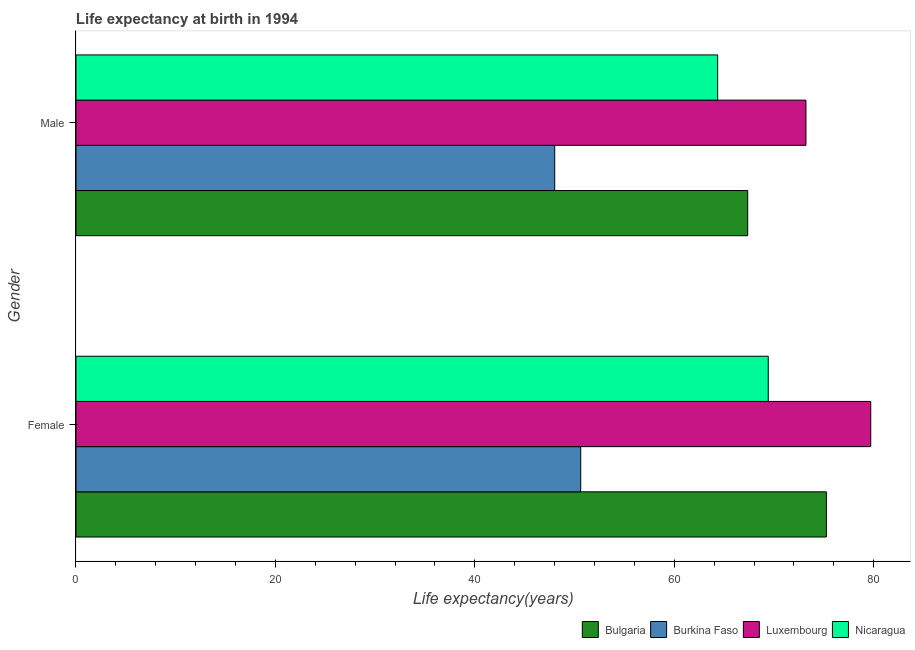Are the number of bars on each tick of the Y-axis equal?
Keep it short and to the point. Yes. How many bars are there on the 2nd tick from the top?
Your response must be concise. 4. What is the life expectancy(female) in Luxembourg?
Provide a short and direct response. 79.7. Across all countries, what is the maximum life expectancy(male)?
Offer a terse response. 73.2. Across all countries, what is the minimum life expectancy(male)?
Give a very brief answer. 48.01. In which country was the life expectancy(female) maximum?
Provide a succinct answer. Luxembourg. In which country was the life expectancy(male) minimum?
Your response must be concise. Burkina Faso. What is the total life expectancy(male) in the graph?
Give a very brief answer. 252.91. What is the difference between the life expectancy(male) in Nicaragua and that in Burkina Faso?
Ensure brevity in your answer.  16.34. What is the difference between the life expectancy(female) in Bulgaria and the life expectancy(male) in Nicaragua?
Give a very brief answer. 10.9. What is the average life expectancy(male) per country?
Give a very brief answer. 63.23. What is the difference between the life expectancy(male) and life expectancy(female) in Nicaragua?
Provide a short and direct response. -5.07. In how many countries, is the life expectancy(female) greater than 76 years?
Make the answer very short. 1. What is the ratio of the life expectancy(male) in Nicaragua to that in Burkina Faso?
Provide a succinct answer. 1.34. Is the life expectancy(male) in Burkina Faso less than that in Luxembourg?
Ensure brevity in your answer.  Yes. In how many countries, is the life expectancy(female) greater than the average life expectancy(female) taken over all countries?
Your response must be concise. 3. What does the 3rd bar from the top in Female represents?
Your answer should be compact. Burkina Faso. What does the 2nd bar from the bottom in Male represents?
Give a very brief answer. Burkina Faso. How many bars are there?
Make the answer very short. 8. Are all the bars in the graph horizontal?
Provide a short and direct response. Yes. How many countries are there in the graph?
Give a very brief answer. 4. What is the difference between two consecutive major ticks on the X-axis?
Provide a succinct answer. 20. Are the values on the major ticks of X-axis written in scientific E-notation?
Offer a terse response. No. What is the title of the graph?
Offer a terse response. Life expectancy at birth in 1994. What is the label or title of the X-axis?
Keep it short and to the point. Life expectancy(years). What is the Life expectancy(years) in Bulgaria in Female?
Provide a short and direct response. 75.25. What is the Life expectancy(years) of Burkina Faso in Female?
Your response must be concise. 50.61. What is the Life expectancy(years) of Luxembourg in Female?
Your answer should be very brief. 79.7. What is the Life expectancy(years) of Nicaragua in Female?
Offer a very short reply. 69.42. What is the Life expectancy(years) of Bulgaria in Male?
Offer a very short reply. 67.36. What is the Life expectancy(years) of Burkina Faso in Male?
Provide a succinct answer. 48.01. What is the Life expectancy(years) of Luxembourg in Male?
Keep it short and to the point. 73.2. What is the Life expectancy(years) in Nicaragua in Male?
Give a very brief answer. 64.35. Across all Gender, what is the maximum Life expectancy(years) of Bulgaria?
Your answer should be compact. 75.25. Across all Gender, what is the maximum Life expectancy(years) in Burkina Faso?
Make the answer very short. 50.61. Across all Gender, what is the maximum Life expectancy(years) of Luxembourg?
Give a very brief answer. 79.7. Across all Gender, what is the maximum Life expectancy(years) of Nicaragua?
Your answer should be very brief. 69.42. Across all Gender, what is the minimum Life expectancy(years) of Bulgaria?
Ensure brevity in your answer.  67.36. Across all Gender, what is the minimum Life expectancy(years) of Burkina Faso?
Ensure brevity in your answer.  48.01. Across all Gender, what is the minimum Life expectancy(years) in Luxembourg?
Make the answer very short. 73.2. Across all Gender, what is the minimum Life expectancy(years) in Nicaragua?
Offer a very short reply. 64.35. What is the total Life expectancy(years) of Bulgaria in the graph?
Your answer should be very brief. 142.61. What is the total Life expectancy(years) in Burkina Faso in the graph?
Your response must be concise. 98.62. What is the total Life expectancy(years) in Luxembourg in the graph?
Your response must be concise. 152.9. What is the total Life expectancy(years) of Nicaragua in the graph?
Your answer should be very brief. 133.77. What is the difference between the Life expectancy(years) in Bulgaria in Female and that in Male?
Provide a succinct answer. 7.89. What is the difference between the Life expectancy(years) in Burkina Faso in Female and that in Male?
Keep it short and to the point. 2.61. What is the difference between the Life expectancy(years) of Nicaragua in Female and that in Male?
Ensure brevity in your answer.  5.07. What is the difference between the Life expectancy(years) in Bulgaria in Female and the Life expectancy(years) in Burkina Faso in Male?
Offer a terse response. 27.24. What is the difference between the Life expectancy(years) of Bulgaria in Female and the Life expectancy(years) of Luxembourg in Male?
Offer a terse response. 2.05. What is the difference between the Life expectancy(years) in Bulgaria in Female and the Life expectancy(years) in Nicaragua in Male?
Your answer should be very brief. 10.9. What is the difference between the Life expectancy(years) of Burkina Faso in Female and the Life expectancy(years) of Luxembourg in Male?
Your answer should be very brief. -22.59. What is the difference between the Life expectancy(years) in Burkina Faso in Female and the Life expectancy(years) in Nicaragua in Male?
Provide a short and direct response. -13.73. What is the difference between the Life expectancy(years) of Luxembourg in Female and the Life expectancy(years) of Nicaragua in Male?
Offer a terse response. 15.35. What is the average Life expectancy(years) in Bulgaria per Gender?
Ensure brevity in your answer.  71.31. What is the average Life expectancy(years) of Burkina Faso per Gender?
Your answer should be compact. 49.31. What is the average Life expectancy(years) in Luxembourg per Gender?
Your response must be concise. 76.45. What is the average Life expectancy(years) of Nicaragua per Gender?
Offer a very short reply. 66.88. What is the difference between the Life expectancy(years) of Bulgaria and Life expectancy(years) of Burkina Faso in Female?
Offer a terse response. 24.64. What is the difference between the Life expectancy(years) of Bulgaria and Life expectancy(years) of Luxembourg in Female?
Your response must be concise. -4.45. What is the difference between the Life expectancy(years) of Bulgaria and Life expectancy(years) of Nicaragua in Female?
Your response must be concise. 5.83. What is the difference between the Life expectancy(years) in Burkina Faso and Life expectancy(years) in Luxembourg in Female?
Provide a short and direct response. -29.09. What is the difference between the Life expectancy(years) in Burkina Faso and Life expectancy(years) in Nicaragua in Female?
Provide a short and direct response. -18.81. What is the difference between the Life expectancy(years) in Luxembourg and Life expectancy(years) in Nicaragua in Female?
Your answer should be very brief. 10.28. What is the difference between the Life expectancy(years) of Bulgaria and Life expectancy(years) of Burkina Faso in Male?
Your answer should be very brief. 19.35. What is the difference between the Life expectancy(years) in Bulgaria and Life expectancy(years) in Luxembourg in Male?
Ensure brevity in your answer.  -5.84. What is the difference between the Life expectancy(years) in Bulgaria and Life expectancy(years) in Nicaragua in Male?
Your response must be concise. 3.01. What is the difference between the Life expectancy(years) in Burkina Faso and Life expectancy(years) in Luxembourg in Male?
Offer a very short reply. -25.19. What is the difference between the Life expectancy(years) in Burkina Faso and Life expectancy(years) in Nicaragua in Male?
Keep it short and to the point. -16.34. What is the difference between the Life expectancy(years) in Luxembourg and Life expectancy(years) in Nicaragua in Male?
Your answer should be compact. 8.85. What is the ratio of the Life expectancy(years) in Bulgaria in Female to that in Male?
Offer a terse response. 1.12. What is the ratio of the Life expectancy(years) in Burkina Faso in Female to that in Male?
Offer a very short reply. 1.05. What is the ratio of the Life expectancy(years) in Luxembourg in Female to that in Male?
Provide a succinct answer. 1.09. What is the ratio of the Life expectancy(years) in Nicaragua in Female to that in Male?
Your answer should be very brief. 1.08. What is the difference between the highest and the second highest Life expectancy(years) of Bulgaria?
Make the answer very short. 7.89. What is the difference between the highest and the second highest Life expectancy(years) of Burkina Faso?
Offer a very short reply. 2.61. What is the difference between the highest and the second highest Life expectancy(years) in Nicaragua?
Make the answer very short. 5.07. What is the difference between the highest and the lowest Life expectancy(years) in Bulgaria?
Provide a short and direct response. 7.89. What is the difference between the highest and the lowest Life expectancy(years) in Burkina Faso?
Offer a terse response. 2.61. What is the difference between the highest and the lowest Life expectancy(years) in Luxembourg?
Your answer should be compact. 6.5. What is the difference between the highest and the lowest Life expectancy(years) in Nicaragua?
Keep it short and to the point. 5.07. 